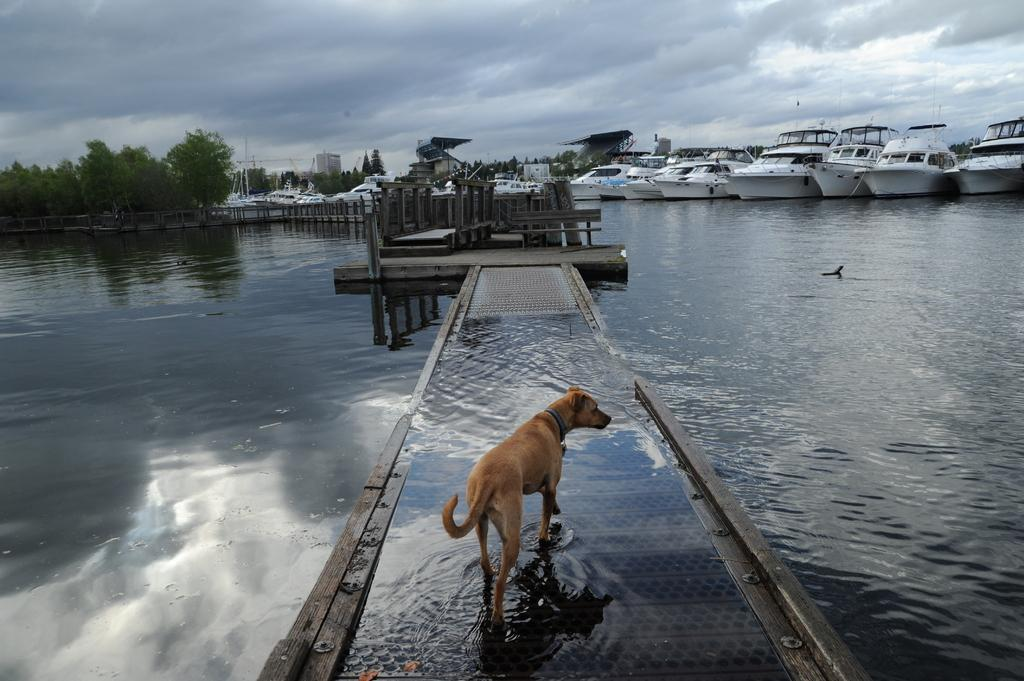What is the main feature of the image? The main feature of the image is water. What is on the water in the image? There are boats on the water in the image. What type of structure is present in the image? There is a board bridge in the image. What type of animal can be seen in the image? There is a dog in the image. What type of vegetation is present in the image? There are trees in the image. What type of man-made structures are present in the image? There are buildings in the image. What part of the natural environment is visible in the image? The sky is visible in the image. What type of potato is being harvested in the image? There is no potato present in the image; it features water, boats, a board bridge, a dog, trees, buildings, and the sky. 